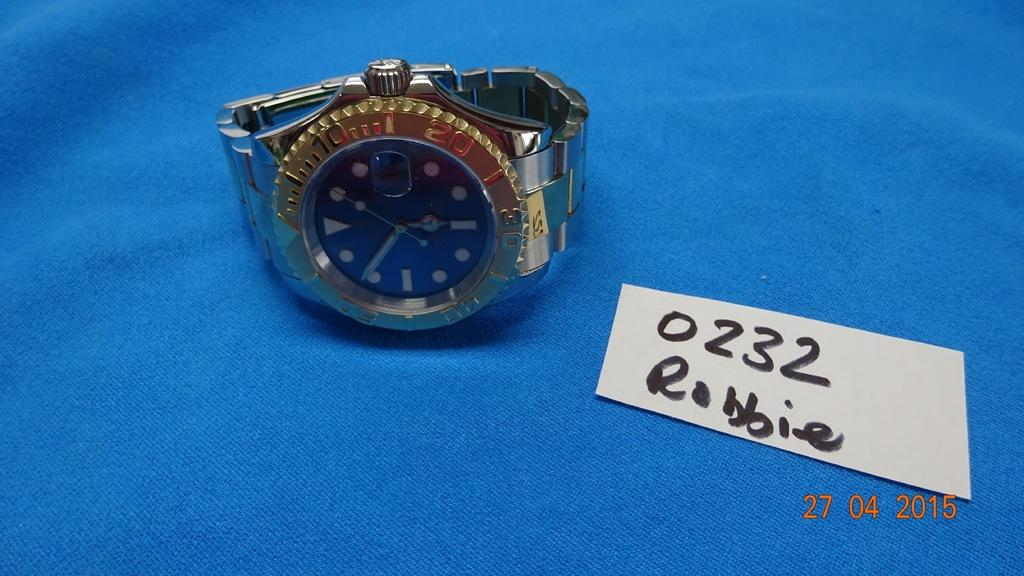<image>
Write a terse but informative summary of the picture. Wrist watch next to a white sign that says Robbie. 